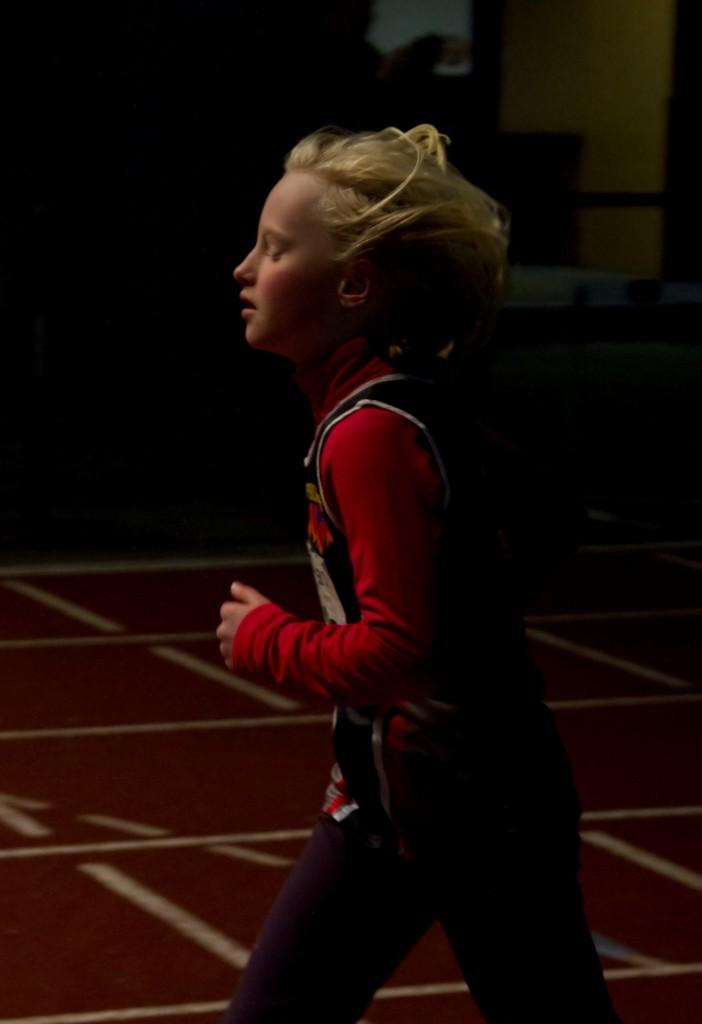Who or what is present in the image? There is a person in the image. What is the person wearing? The person is wearing a red and black colored dress. What color is the floor in the image? The floor in the image is brown colored. How would you describe the background of the image? The background of the image is dark. How many babies are crawling on the floor in the image? There are no babies present in the image; it features a person wearing a red and black colored dress with a dark background. What type of bean is being roasted in the background of the image? There is no bean or any indication of roasting in the image; it only shows a person wearing a dress with a dark background. 